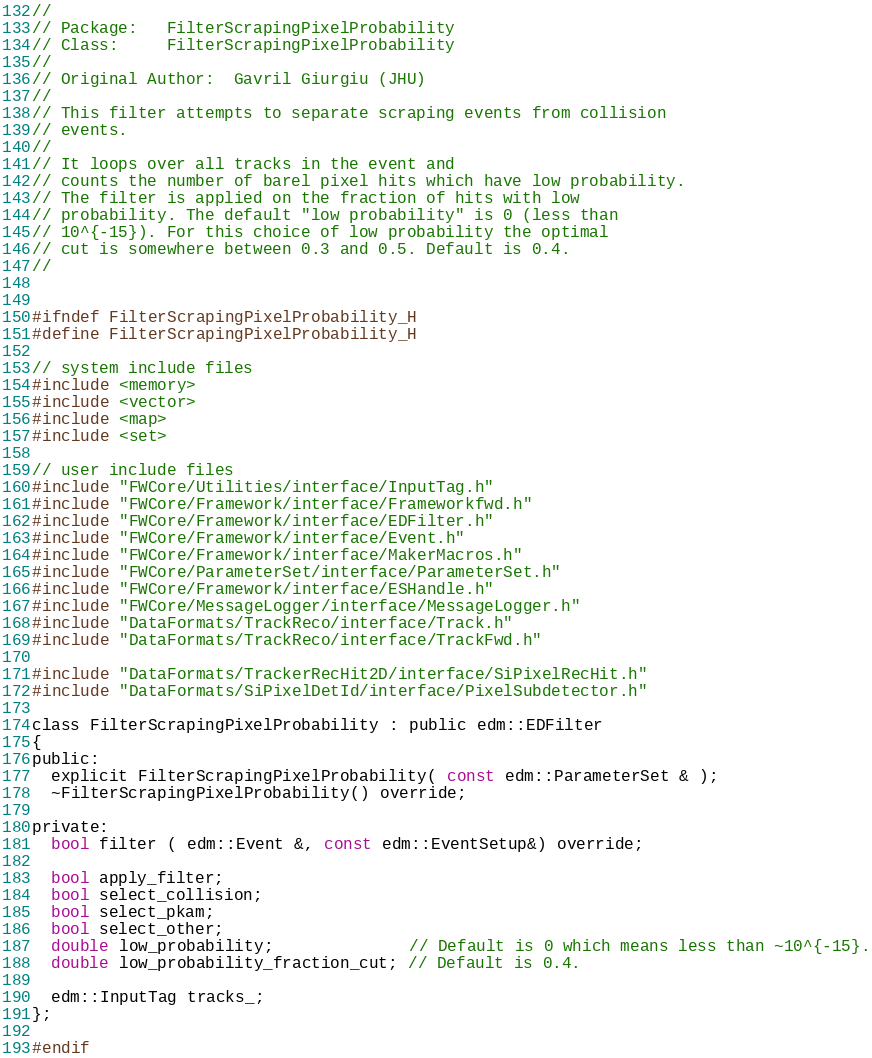Convert code to text. <code><loc_0><loc_0><loc_500><loc_500><_C_>//
// Package:   FilterScrapingPixelProbability
// Class:     FilterScrapingPixelProbability
//
// Original Author:  Gavril Giurgiu (JHU)
//
// This filter attempts to separate scraping events from collision 
// events. 
//
// It loops over all tracks in the event and 
// counts the number of barel pixel hits which have low probability. 
// The filter is applied on the fraction of hits with low 
// probability. The default "low probability" is 0 (less than 
// 10^{-15}). For this choice of low probability the optimal  
// cut is somewhere between 0.3 and 0.5. Default is 0.4. 
//


#ifndef FilterScrapingPixelProbability_H
#define FilterScrapingPixelProbability_H

// system include files
#include <memory>
#include <vector>
#include <map>
#include <set>

// user include files
#include "FWCore/Utilities/interface/InputTag.h"
#include "FWCore/Framework/interface/Frameworkfwd.h"
#include "FWCore/Framework/interface/EDFilter.h"
#include "FWCore/Framework/interface/Event.h"
#include "FWCore/Framework/interface/MakerMacros.h"
#include "FWCore/ParameterSet/interface/ParameterSet.h"
#include "FWCore/Framework/interface/ESHandle.h"
#include "FWCore/MessageLogger/interface/MessageLogger.h"
#include "DataFormats/TrackReco/interface/Track.h"
#include "DataFormats/TrackReco/interface/TrackFwd.h"

#include "DataFormats/TrackerRecHit2D/interface/SiPixelRecHit.h"
#include "DataFormats/SiPixelDetId/interface/PixelSubdetector.h"

class FilterScrapingPixelProbability : public edm::EDFilter 
{
public:
  explicit FilterScrapingPixelProbability( const edm::ParameterSet & );
  ~FilterScrapingPixelProbability() override;
  
private:
  bool filter ( edm::Event &, const edm::EventSetup&) override;
  
  bool apply_filter;
  bool select_collision;
  bool select_pkam;
  bool select_other;
  double low_probability;              // Default is 0 which means less than ~10^{-15}.
  double low_probability_fraction_cut; // Default is 0.4.

  edm::InputTag tracks_;
};

#endif
</code> 